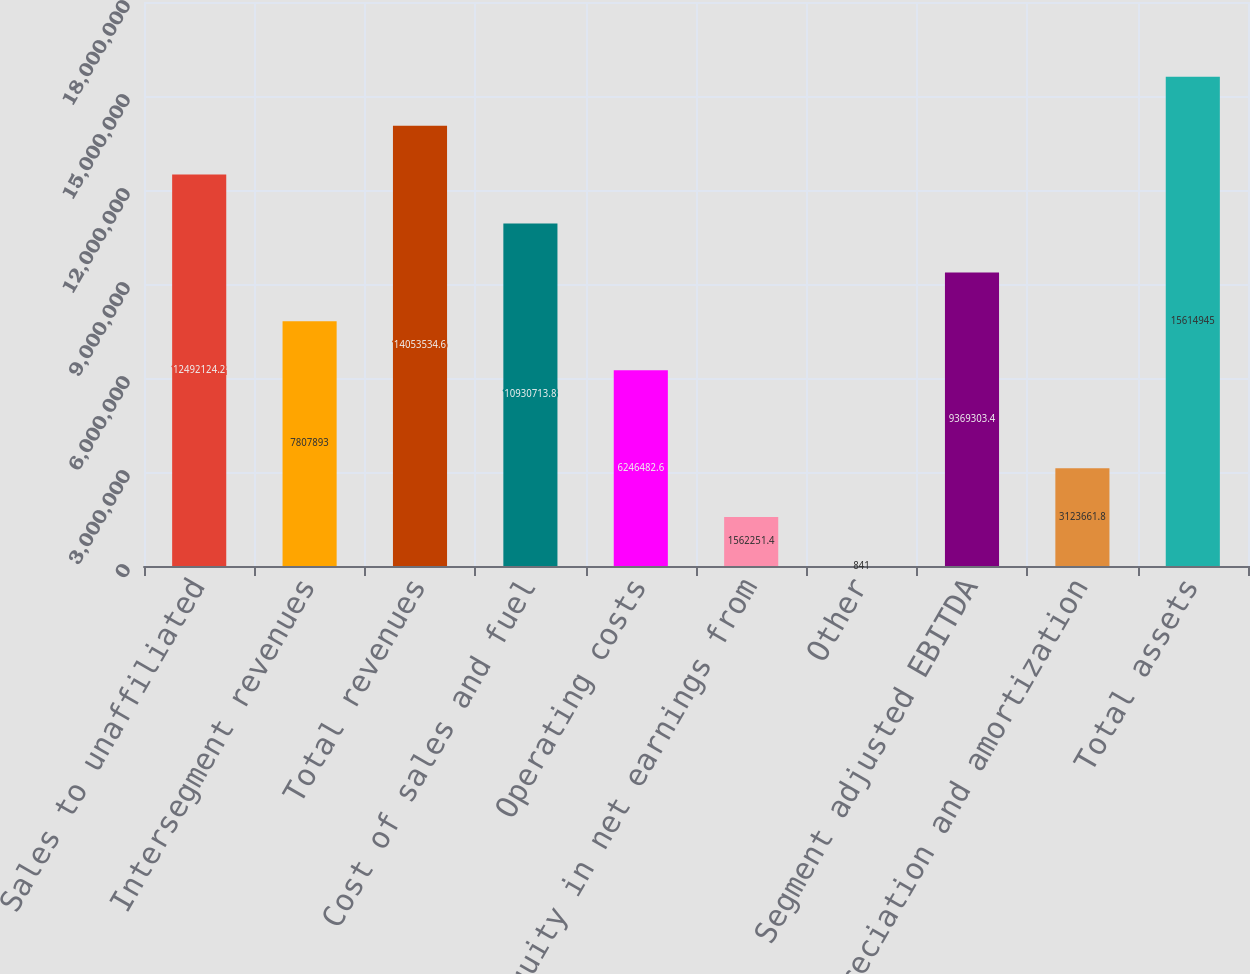Convert chart. <chart><loc_0><loc_0><loc_500><loc_500><bar_chart><fcel>Sales to unaffiliated<fcel>Intersegment revenues<fcel>Total revenues<fcel>Cost of sales and fuel<fcel>Operating costs<fcel>Equity in net earnings from<fcel>Other<fcel>Segment adjusted EBITDA<fcel>Depreciation and amortization<fcel>Total assets<nl><fcel>1.24921e+07<fcel>7.80789e+06<fcel>1.40535e+07<fcel>1.09307e+07<fcel>6.24648e+06<fcel>1.56225e+06<fcel>841<fcel>9.3693e+06<fcel>3.12366e+06<fcel>1.56149e+07<nl></chart> 